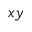Convert formula to latex. <formula><loc_0><loc_0><loc_500><loc_500>x y</formula> 